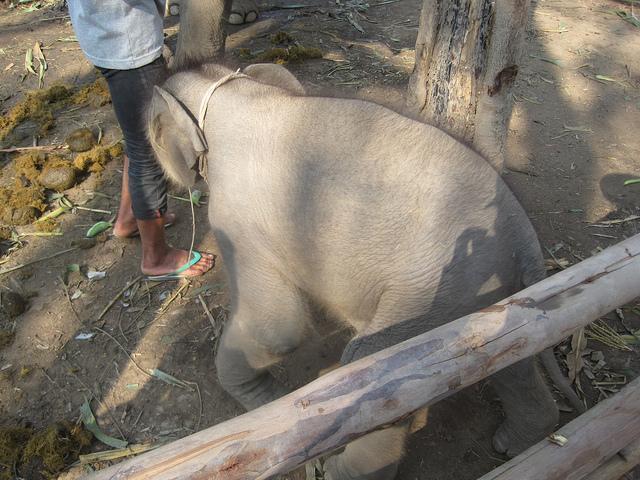How many people are there?
Give a very brief answer. 1. 